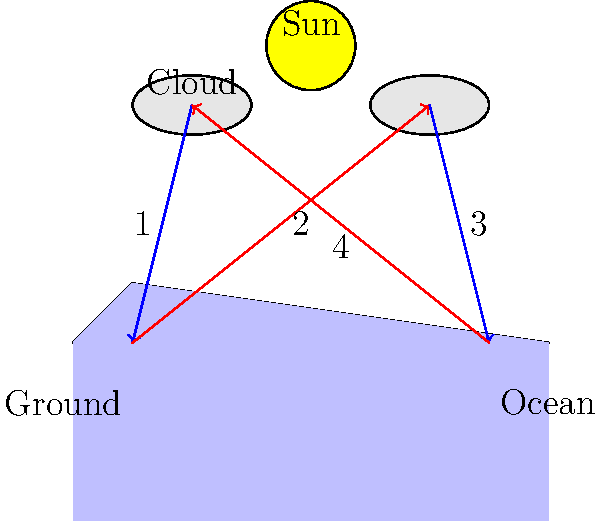In the water cycle diagram above, which number represents the process of evaporation? To answer this question, let's break down the water cycle processes shown in the diagram:

1. The blue arrow labeled "1" shows water moving from the cloud to the ground. This represents precipitation (rain or snow).

2. The red arrow labeled "2" shows water moving from the ground to the cloud. This represents evaporation and transpiration from land.

3. The blue arrow labeled "3" shows water moving from the cloud to the ocean. This also represents precipitation.

4. The red arrow labeled "4" shows water moving from the ocean to the cloud. This represents evaporation from the ocean surface.

Evaporation is the process by which water changes from a liquid to a gas or vapor. In the water cycle, this occurs primarily from the surface of water bodies (like oceans) and from the land.

Looking at the diagram, we can see that the arrows representing evaporation are colored red and moving upward. There are two such arrows: number 2 (from land) and number 4 (from the ocean).

Since the question asks specifically about evaporation, and the most significant source of evaporation in the global water cycle is from oceans, the correct answer is number 4.
Answer: 4 